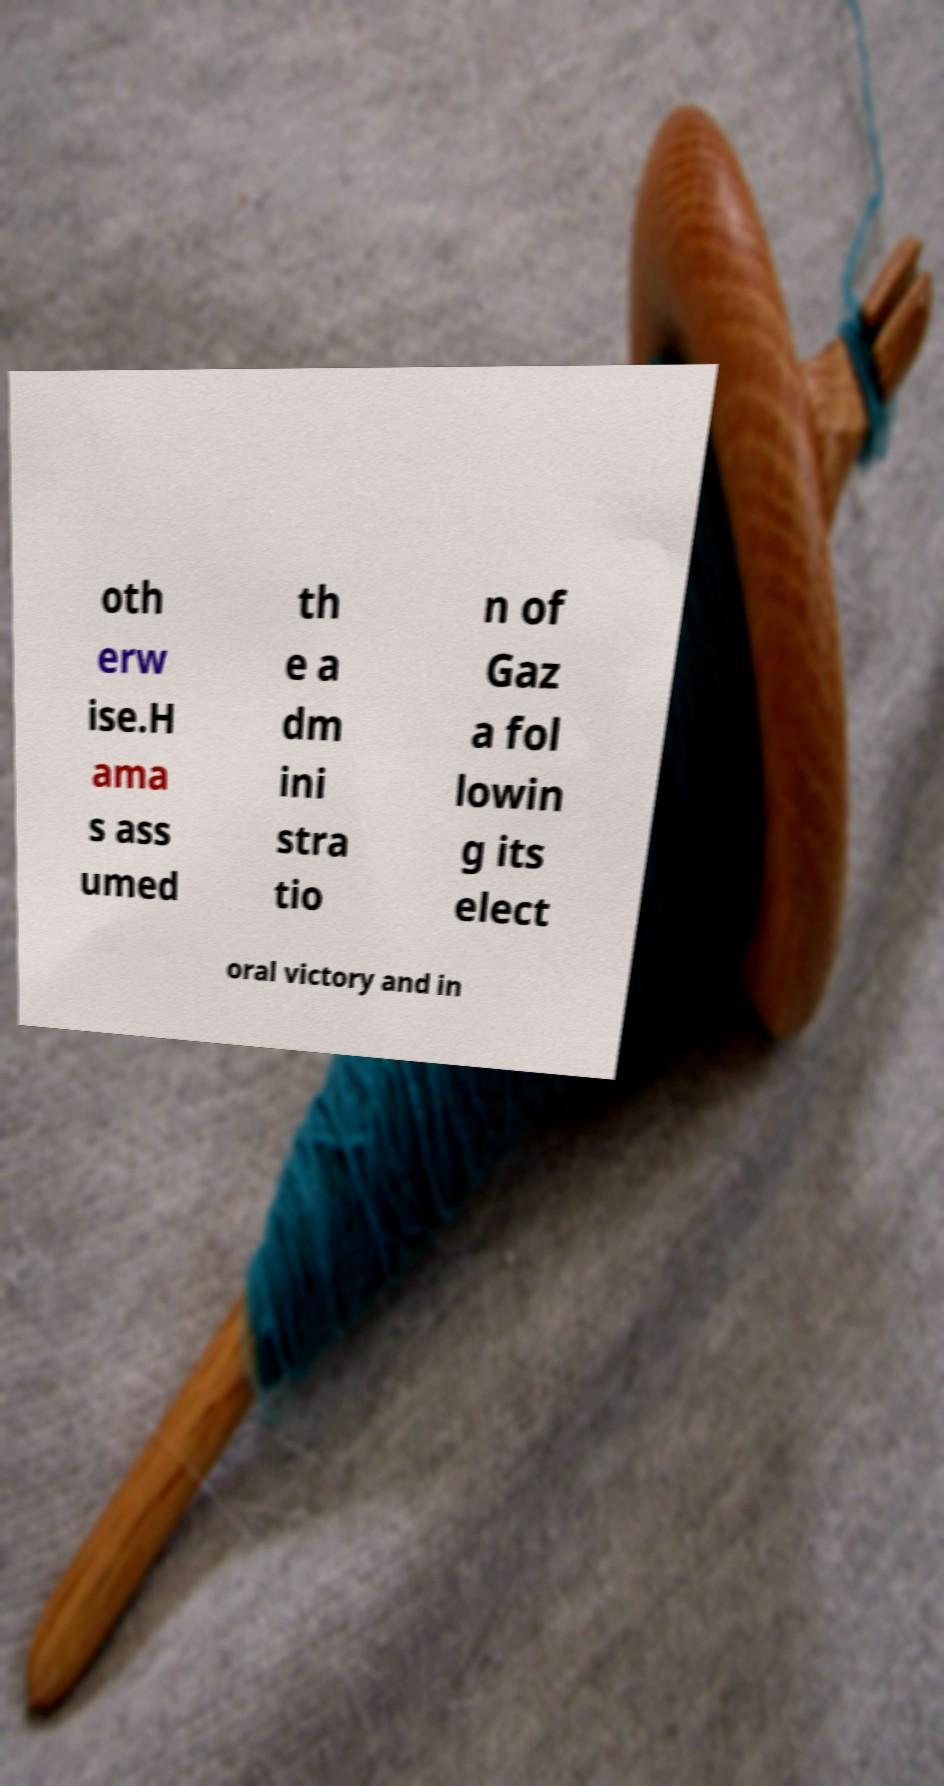For documentation purposes, I need the text within this image transcribed. Could you provide that? oth erw ise.H ama s ass umed th e a dm ini stra tio n of Gaz a fol lowin g its elect oral victory and in 